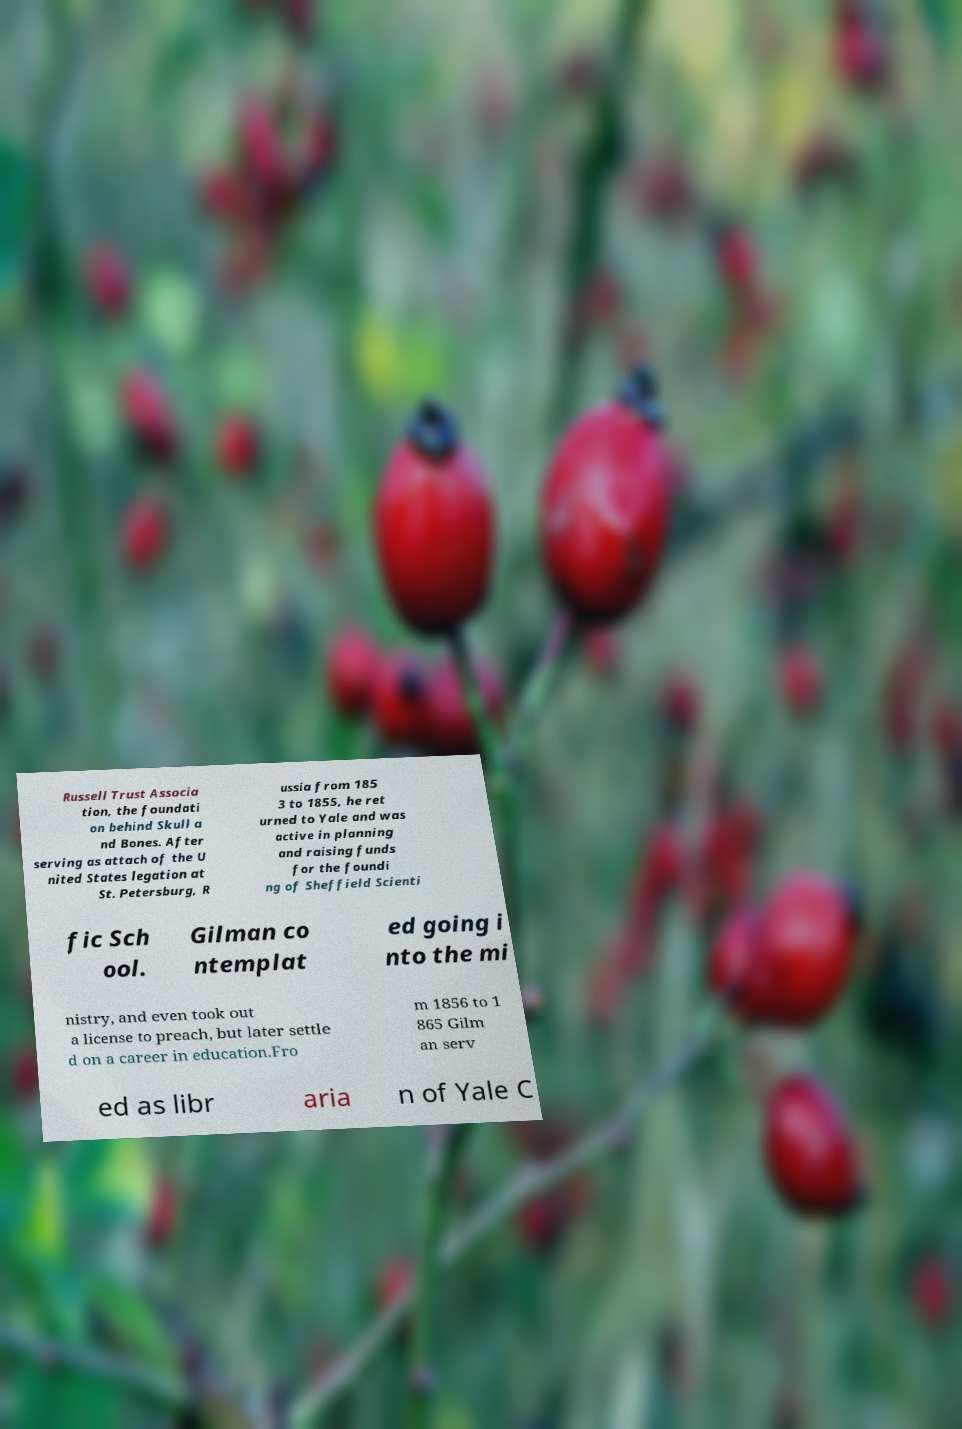Can you accurately transcribe the text from the provided image for me? Russell Trust Associa tion, the foundati on behind Skull a nd Bones. After serving as attach of the U nited States legation at St. Petersburg, R ussia from 185 3 to 1855, he ret urned to Yale and was active in planning and raising funds for the foundi ng of Sheffield Scienti fic Sch ool. Gilman co ntemplat ed going i nto the mi nistry, and even took out a license to preach, but later settle d on a career in education.Fro m 1856 to 1 865 Gilm an serv ed as libr aria n of Yale C 